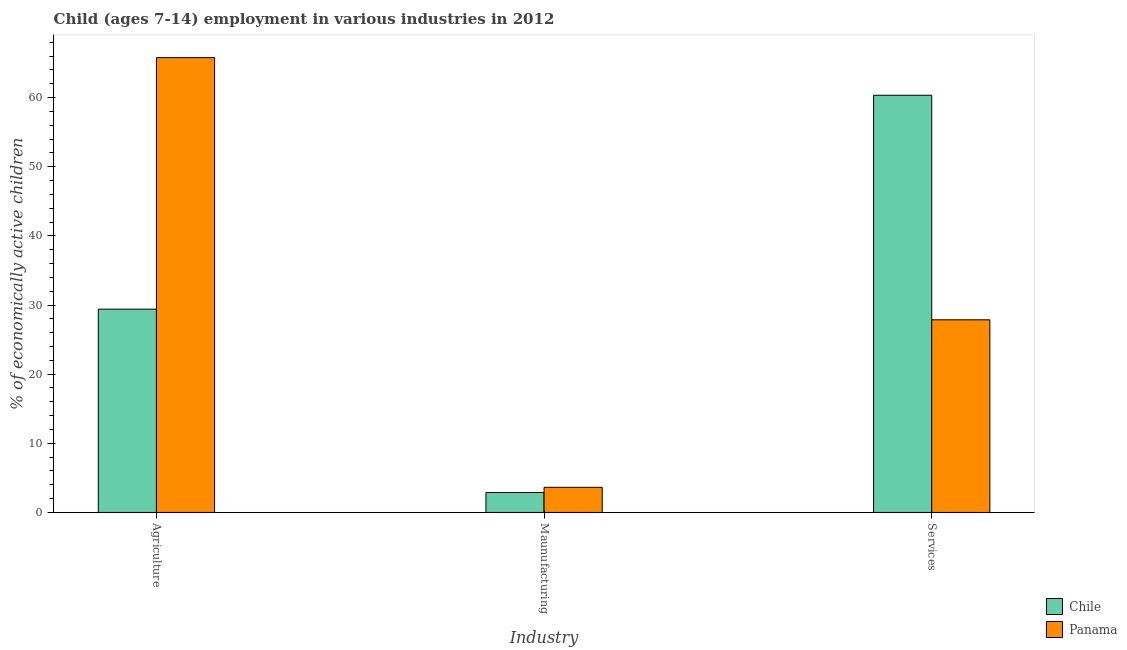How many groups of bars are there?
Keep it short and to the point. 3. Are the number of bars per tick equal to the number of legend labels?
Provide a short and direct response. Yes. Are the number of bars on each tick of the X-axis equal?
Your answer should be compact. Yes. What is the label of the 1st group of bars from the left?
Offer a terse response. Agriculture. What is the percentage of economically active children in agriculture in Panama?
Offer a terse response. 65.77. Across all countries, what is the maximum percentage of economically active children in services?
Your response must be concise. 60.33. Across all countries, what is the minimum percentage of economically active children in services?
Give a very brief answer. 27.86. What is the total percentage of economically active children in services in the graph?
Provide a short and direct response. 88.19. What is the difference between the percentage of economically active children in agriculture in Chile and that in Panama?
Give a very brief answer. -36.37. What is the difference between the percentage of economically active children in services in Panama and the percentage of economically active children in manufacturing in Chile?
Offer a terse response. 24.97. What is the average percentage of economically active children in manufacturing per country?
Provide a short and direct response. 3.27. What is the difference between the percentage of economically active children in services and percentage of economically active children in manufacturing in Panama?
Make the answer very short. 24.22. In how many countries, is the percentage of economically active children in services greater than 28 %?
Your response must be concise. 1. What is the ratio of the percentage of economically active children in agriculture in Chile to that in Panama?
Give a very brief answer. 0.45. Is the difference between the percentage of economically active children in services in Chile and Panama greater than the difference between the percentage of economically active children in manufacturing in Chile and Panama?
Give a very brief answer. Yes. What is the difference between the highest and the second highest percentage of economically active children in agriculture?
Offer a very short reply. 36.37. What is the difference between the highest and the lowest percentage of economically active children in agriculture?
Offer a terse response. 36.37. What does the 1st bar from the left in Agriculture represents?
Make the answer very short. Chile. What does the 2nd bar from the right in Services represents?
Offer a very short reply. Chile. Are the values on the major ticks of Y-axis written in scientific E-notation?
Offer a terse response. No. Where does the legend appear in the graph?
Offer a very short reply. Bottom right. How many legend labels are there?
Offer a terse response. 2. How are the legend labels stacked?
Offer a terse response. Vertical. What is the title of the graph?
Keep it short and to the point. Child (ages 7-14) employment in various industries in 2012. Does "Canada" appear as one of the legend labels in the graph?
Your response must be concise. No. What is the label or title of the X-axis?
Ensure brevity in your answer.  Industry. What is the label or title of the Y-axis?
Keep it short and to the point. % of economically active children. What is the % of economically active children of Chile in Agriculture?
Keep it short and to the point. 29.4. What is the % of economically active children in Panama in Agriculture?
Your answer should be compact. 65.77. What is the % of economically active children of Chile in Maunufacturing?
Provide a short and direct response. 2.89. What is the % of economically active children in Panama in Maunufacturing?
Your answer should be very brief. 3.64. What is the % of economically active children in Chile in Services?
Give a very brief answer. 60.33. What is the % of economically active children in Panama in Services?
Provide a succinct answer. 27.86. Across all Industry, what is the maximum % of economically active children of Chile?
Offer a very short reply. 60.33. Across all Industry, what is the maximum % of economically active children of Panama?
Give a very brief answer. 65.77. Across all Industry, what is the minimum % of economically active children of Chile?
Make the answer very short. 2.89. Across all Industry, what is the minimum % of economically active children of Panama?
Provide a short and direct response. 3.64. What is the total % of economically active children in Chile in the graph?
Keep it short and to the point. 92.62. What is the total % of economically active children of Panama in the graph?
Your response must be concise. 97.27. What is the difference between the % of economically active children in Chile in Agriculture and that in Maunufacturing?
Offer a very short reply. 26.51. What is the difference between the % of economically active children of Panama in Agriculture and that in Maunufacturing?
Offer a terse response. 62.13. What is the difference between the % of economically active children in Chile in Agriculture and that in Services?
Your answer should be very brief. -30.93. What is the difference between the % of economically active children of Panama in Agriculture and that in Services?
Make the answer very short. 37.91. What is the difference between the % of economically active children in Chile in Maunufacturing and that in Services?
Make the answer very short. -57.44. What is the difference between the % of economically active children in Panama in Maunufacturing and that in Services?
Your answer should be compact. -24.22. What is the difference between the % of economically active children of Chile in Agriculture and the % of economically active children of Panama in Maunufacturing?
Offer a terse response. 25.76. What is the difference between the % of economically active children in Chile in Agriculture and the % of economically active children in Panama in Services?
Offer a very short reply. 1.54. What is the difference between the % of economically active children in Chile in Maunufacturing and the % of economically active children in Panama in Services?
Give a very brief answer. -24.97. What is the average % of economically active children of Chile per Industry?
Offer a very short reply. 30.87. What is the average % of economically active children of Panama per Industry?
Your answer should be very brief. 32.42. What is the difference between the % of economically active children in Chile and % of economically active children in Panama in Agriculture?
Your answer should be very brief. -36.37. What is the difference between the % of economically active children in Chile and % of economically active children in Panama in Maunufacturing?
Provide a succinct answer. -0.75. What is the difference between the % of economically active children in Chile and % of economically active children in Panama in Services?
Your answer should be very brief. 32.47. What is the ratio of the % of economically active children of Chile in Agriculture to that in Maunufacturing?
Offer a very short reply. 10.17. What is the ratio of the % of economically active children in Panama in Agriculture to that in Maunufacturing?
Make the answer very short. 18.07. What is the ratio of the % of economically active children of Chile in Agriculture to that in Services?
Ensure brevity in your answer.  0.49. What is the ratio of the % of economically active children of Panama in Agriculture to that in Services?
Your answer should be very brief. 2.36. What is the ratio of the % of economically active children in Chile in Maunufacturing to that in Services?
Your answer should be very brief. 0.05. What is the ratio of the % of economically active children of Panama in Maunufacturing to that in Services?
Provide a short and direct response. 0.13. What is the difference between the highest and the second highest % of economically active children in Chile?
Keep it short and to the point. 30.93. What is the difference between the highest and the second highest % of economically active children in Panama?
Make the answer very short. 37.91. What is the difference between the highest and the lowest % of economically active children in Chile?
Offer a terse response. 57.44. What is the difference between the highest and the lowest % of economically active children in Panama?
Your answer should be compact. 62.13. 